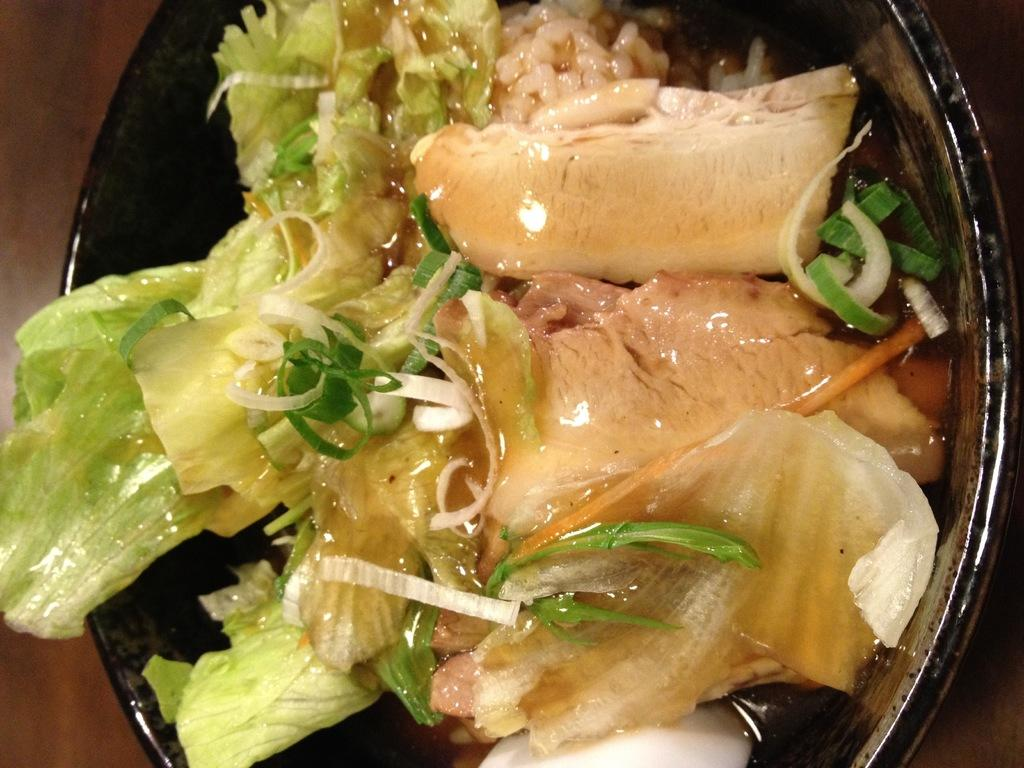What is in the image that is used for holding food? There is a bowl in the image that is used for holding food. What color is the bowl in the image? The bowl is black in color. What can be seen inside the bowl? The bowl contains food that is in cream and green colors. Where is the bowl located in the image? The bowl is placed on a table. What is the color of the table in the image? The table is brown in color. Can you tell me how many writers are visible in the image? There are no writers present in the image; it only features a black bowl containing food on a brown table. 